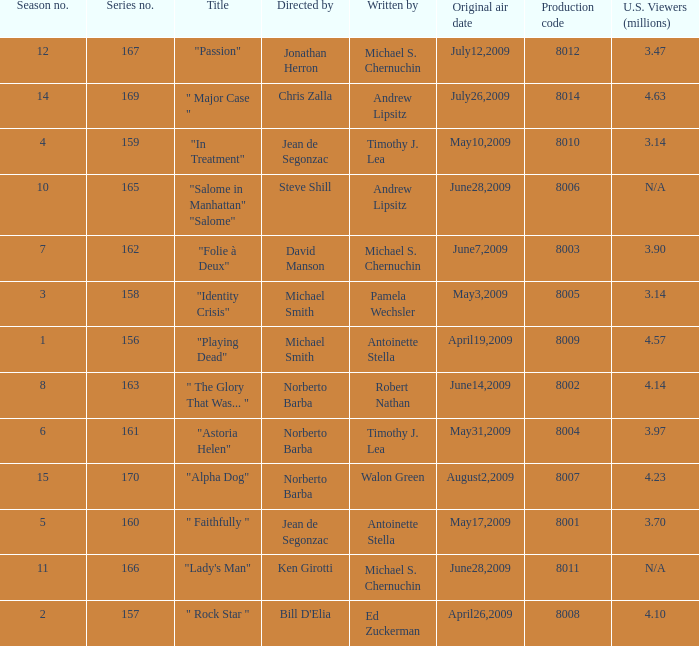Who are the writers when the production code is 8011? Michael S. Chernuchin. 